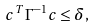<formula> <loc_0><loc_0><loc_500><loc_500>c ^ { T } \Gamma ^ { - 1 } c \leq \delta ,</formula> 